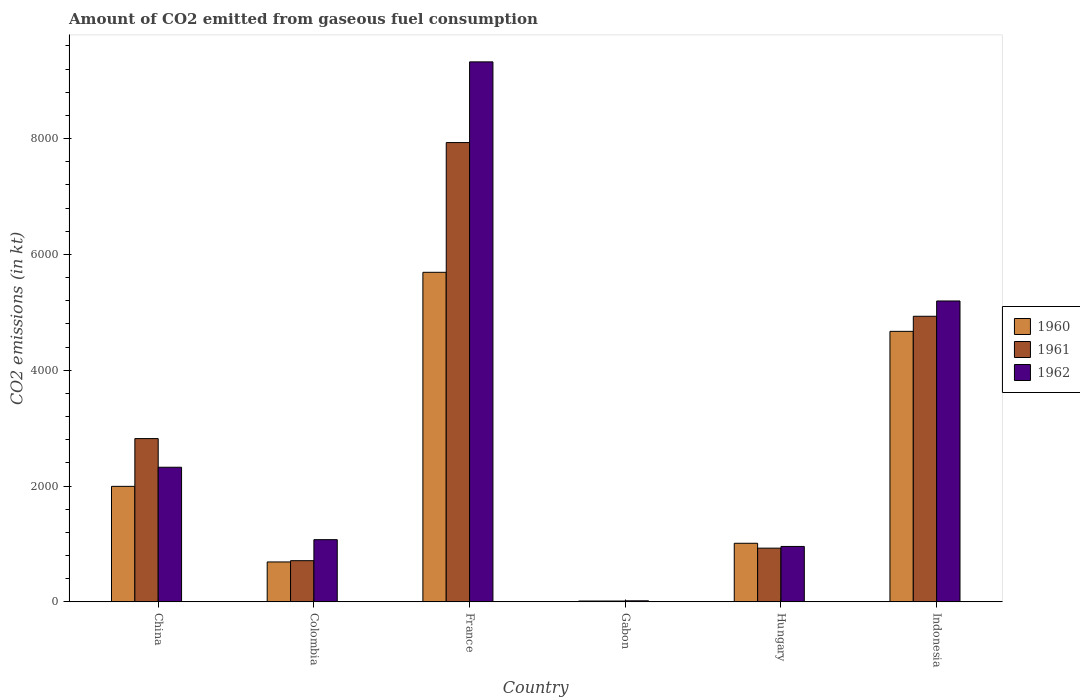How many groups of bars are there?
Offer a very short reply. 6. Are the number of bars per tick equal to the number of legend labels?
Offer a very short reply. Yes. Are the number of bars on each tick of the X-axis equal?
Provide a short and direct response. Yes. How many bars are there on the 5th tick from the right?
Offer a very short reply. 3. What is the label of the 2nd group of bars from the left?
Your response must be concise. Colombia. What is the amount of CO2 emitted in 1962 in Colombia?
Offer a terse response. 1074.43. Across all countries, what is the maximum amount of CO2 emitted in 1960?
Your response must be concise. 5691.18. Across all countries, what is the minimum amount of CO2 emitted in 1962?
Provide a short and direct response. 18.34. In which country was the amount of CO2 emitted in 1961 maximum?
Your response must be concise. France. In which country was the amount of CO2 emitted in 1960 minimum?
Ensure brevity in your answer.  Gabon. What is the total amount of CO2 emitted in 1960 in the graph?
Your answer should be very brief. 1.41e+04. What is the difference between the amount of CO2 emitted in 1961 in China and that in Indonesia?
Give a very brief answer. -2112.19. What is the difference between the amount of CO2 emitted in 1960 in Hungary and the amount of CO2 emitted in 1962 in Gabon?
Your answer should be compact. 993.76. What is the average amount of CO2 emitted in 1961 per country?
Give a very brief answer. 2889.6. What is the difference between the amount of CO2 emitted of/in 1962 and amount of CO2 emitted of/in 1960 in France?
Keep it short and to the point. 3634. What is the ratio of the amount of CO2 emitted in 1962 in Hungary to that in Indonesia?
Give a very brief answer. 0.18. Is the difference between the amount of CO2 emitted in 1962 in Colombia and Gabon greater than the difference between the amount of CO2 emitted in 1960 in Colombia and Gabon?
Your answer should be very brief. Yes. What is the difference between the highest and the second highest amount of CO2 emitted in 1962?
Keep it short and to the point. -2871.26. What is the difference between the highest and the lowest amount of CO2 emitted in 1960?
Make the answer very short. 5676.52. In how many countries, is the amount of CO2 emitted in 1960 greater than the average amount of CO2 emitted in 1960 taken over all countries?
Your response must be concise. 2. What does the 3rd bar from the left in Indonesia represents?
Give a very brief answer. 1962. What does the 1st bar from the right in Colombia represents?
Provide a succinct answer. 1962. Is it the case that in every country, the sum of the amount of CO2 emitted in 1960 and amount of CO2 emitted in 1961 is greater than the amount of CO2 emitted in 1962?
Your answer should be very brief. Yes. How many countries are there in the graph?
Offer a very short reply. 6. Does the graph contain grids?
Provide a succinct answer. No. Where does the legend appear in the graph?
Provide a short and direct response. Center right. How many legend labels are there?
Give a very brief answer. 3. What is the title of the graph?
Make the answer very short. Amount of CO2 emitted from gaseous fuel consumption. Does "1962" appear as one of the legend labels in the graph?
Make the answer very short. Yes. What is the label or title of the X-axis?
Your answer should be very brief. Country. What is the label or title of the Y-axis?
Offer a very short reply. CO2 emissions (in kt). What is the CO2 emissions (in kt) in 1960 in China?
Your answer should be very brief. 1994.85. What is the CO2 emissions (in kt) of 1961 in China?
Offer a very short reply. 2819.92. What is the CO2 emissions (in kt) in 1962 in China?
Offer a terse response. 2324.88. What is the CO2 emissions (in kt) in 1960 in Colombia?
Provide a short and direct response. 689.4. What is the CO2 emissions (in kt) in 1961 in Colombia?
Ensure brevity in your answer.  711.4. What is the CO2 emissions (in kt) of 1962 in Colombia?
Provide a succinct answer. 1074.43. What is the CO2 emissions (in kt) in 1960 in France?
Keep it short and to the point. 5691.18. What is the CO2 emissions (in kt) in 1961 in France?
Keep it short and to the point. 7931.72. What is the CO2 emissions (in kt) of 1962 in France?
Your answer should be very brief. 9325.18. What is the CO2 emissions (in kt) in 1960 in Gabon?
Your response must be concise. 14.67. What is the CO2 emissions (in kt) in 1961 in Gabon?
Your answer should be very brief. 14.67. What is the CO2 emissions (in kt) of 1962 in Gabon?
Offer a very short reply. 18.34. What is the CO2 emissions (in kt) of 1960 in Hungary?
Keep it short and to the point. 1012.09. What is the CO2 emissions (in kt) in 1961 in Hungary?
Offer a very short reply. 927.75. What is the CO2 emissions (in kt) of 1962 in Hungary?
Offer a very short reply. 957.09. What is the CO2 emissions (in kt) in 1960 in Indonesia?
Your answer should be compact. 4671.76. What is the CO2 emissions (in kt) in 1961 in Indonesia?
Offer a very short reply. 4932.11. What is the CO2 emissions (in kt) in 1962 in Indonesia?
Your response must be concise. 5196.14. Across all countries, what is the maximum CO2 emissions (in kt) of 1960?
Your answer should be compact. 5691.18. Across all countries, what is the maximum CO2 emissions (in kt) of 1961?
Provide a succinct answer. 7931.72. Across all countries, what is the maximum CO2 emissions (in kt) in 1962?
Your answer should be compact. 9325.18. Across all countries, what is the minimum CO2 emissions (in kt) of 1960?
Ensure brevity in your answer.  14.67. Across all countries, what is the minimum CO2 emissions (in kt) in 1961?
Your answer should be compact. 14.67. Across all countries, what is the minimum CO2 emissions (in kt) in 1962?
Make the answer very short. 18.34. What is the total CO2 emissions (in kt) in 1960 in the graph?
Offer a terse response. 1.41e+04. What is the total CO2 emissions (in kt) of 1961 in the graph?
Provide a short and direct response. 1.73e+04. What is the total CO2 emissions (in kt) in 1962 in the graph?
Offer a terse response. 1.89e+04. What is the difference between the CO2 emissions (in kt) in 1960 in China and that in Colombia?
Provide a short and direct response. 1305.45. What is the difference between the CO2 emissions (in kt) in 1961 in China and that in Colombia?
Give a very brief answer. 2108.53. What is the difference between the CO2 emissions (in kt) in 1962 in China and that in Colombia?
Give a very brief answer. 1250.45. What is the difference between the CO2 emissions (in kt) in 1960 in China and that in France?
Keep it short and to the point. -3696.34. What is the difference between the CO2 emissions (in kt) in 1961 in China and that in France?
Give a very brief answer. -5111.8. What is the difference between the CO2 emissions (in kt) in 1962 in China and that in France?
Your answer should be very brief. -7000.3. What is the difference between the CO2 emissions (in kt) in 1960 in China and that in Gabon?
Give a very brief answer. 1980.18. What is the difference between the CO2 emissions (in kt) of 1961 in China and that in Gabon?
Offer a very short reply. 2805.26. What is the difference between the CO2 emissions (in kt) in 1962 in China and that in Gabon?
Ensure brevity in your answer.  2306.54. What is the difference between the CO2 emissions (in kt) of 1960 in China and that in Hungary?
Your answer should be compact. 982.76. What is the difference between the CO2 emissions (in kt) in 1961 in China and that in Hungary?
Provide a succinct answer. 1892.17. What is the difference between the CO2 emissions (in kt) in 1962 in China and that in Hungary?
Provide a succinct answer. 1367.79. What is the difference between the CO2 emissions (in kt) of 1960 in China and that in Indonesia?
Make the answer very short. -2676.91. What is the difference between the CO2 emissions (in kt) of 1961 in China and that in Indonesia?
Offer a very short reply. -2112.19. What is the difference between the CO2 emissions (in kt) in 1962 in China and that in Indonesia?
Provide a succinct answer. -2871.26. What is the difference between the CO2 emissions (in kt) in 1960 in Colombia and that in France?
Your answer should be compact. -5001.79. What is the difference between the CO2 emissions (in kt) of 1961 in Colombia and that in France?
Offer a very short reply. -7220.32. What is the difference between the CO2 emissions (in kt) in 1962 in Colombia and that in France?
Provide a succinct answer. -8250.75. What is the difference between the CO2 emissions (in kt) of 1960 in Colombia and that in Gabon?
Provide a succinct answer. 674.73. What is the difference between the CO2 emissions (in kt) of 1961 in Colombia and that in Gabon?
Offer a very short reply. 696.73. What is the difference between the CO2 emissions (in kt) of 1962 in Colombia and that in Gabon?
Your answer should be very brief. 1056.1. What is the difference between the CO2 emissions (in kt) of 1960 in Colombia and that in Hungary?
Provide a short and direct response. -322.7. What is the difference between the CO2 emissions (in kt) in 1961 in Colombia and that in Hungary?
Your answer should be very brief. -216.35. What is the difference between the CO2 emissions (in kt) of 1962 in Colombia and that in Hungary?
Provide a short and direct response. 117.34. What is the difference between the CO2 emissions (in kt) in 1960 in Colombia and that in Indonesia?
Offer a very short reply. -3982.36. What is the difference between the CO2 emissions (in kt) of 1961 in Colombia and that in Indonesia?
Make the answer very short. -4220.72. What is the difference between the CO2 emissions (in kt) in 1962 in Colombia and that in Indonesia?
Give a very brief answer. -4121.71. What is the difference between the CO2 emissions (in kt) of 1960 in France and that in Gabon?
Your answer should be compact. 5676.52. What is the difference between the CO2 emissions (in kt) of 1961 in France and that in Gabon?
Make the answer very short. 7917.05. What is the difference between the CO2 emissions (in kt) in 1962 in France and that in Gabon?
Keep it short and to the point. 9306.85. What is the difference between the CO2 emissions (in kt) in 1960 in France and that in Hungary?
Give a very brief answer. 4679.09. What is the difference between the CO2 emissions (in kt) in 1961 in France and that in Hungary?
Your response must be concise. 7003.97. What is the difference between the CO2 emissions (in kt) in 1962 in France and that in Hungary?
Make the answer very short. 8368.09. What is the difference between the CO2 emissions (in kt) in 1960 in France and that in Indonesia?
Provide a short and direct response. 1019.43. What is the difference between the CO2 emissions (in kt) in 1961 in France and that in Indonesia?
Provide a short and direct response. 2999.61. What is the difference between the CO2 emissions (in kt) in 1962 in France and that in Indonesia?
Keep it short and to the point. 4129.04. What is the difference between the CO2 emissions (in kt) of 1960 in Gabon and that in Hungary?
Ensure brevity in your answer.  -997.42. What is the difference between the CO2 emissions (in kt) of 1961 in Gabon and that in Hungary?
Your answer should be very brief. -913.08. What is the difference between the CO2 emissions (in kt) of 1962 in Gabon and that in Hungary?
Give a very brief answer. -938.75. What is the difference between the CO2 emissions (in kt) of 1960 in Gabon and that in Indonesia?
Your response must be concise. -4657.09. What is the difference between the CO2 emissions (in kt) of 1961 in Gabon and that in Indonesia?
Keep it short and to the point. -4917.45. What is the difference between the CO2 emissions (in kt) in 1962 in Gabon and that in Indonesia?
Provide a short and direct response. -5177.8. What is the difference between the CO2 emissions (in kt) in 1960 in Hungary and that in Indonesia?
Offer a terse response. -3659.67. What is the difference between the CO2 emissions (in kt) in 1961 in Hungary and that in Indonesia?
Your answer should be compact. -4004.36. What is the difference between the CO2 emissions (in kt) in 1962 in Hungary and that in Indonesia?
Your response must be concise. -4239.05. What is the difference between the CO2 emissions (in kt) of 1960 in China and the CO2 emissions (in kt) of 1961 in Colombia?
Offer a terse response. 1283.45. What is the difference between the CO2 emissions (in kt) in 1960 in China and the CO2 emissions (in kt) in 1962 in Colombia?
Offer a very short reply. 920.42. What is the difference between the CO2 emissions (in kt) in 1961 in China and the CO2 emissions (in kt) in 1962 in Colombia?
Keep it short and to the point. 1745.49. What is the difference between the CO2 emissions (in kt) in 1960 in China and the CO2 emissions (in kt) in 1961 in France?
Ensure brevity in your answer.  -5936.87. What is the difference between the CO2 emissions (in kt) of 1960 in China and the CO2 emissions (in kt) of 1962 in France?
Ensure brevity in your answer.  -7330.33. What is the difference between the CO2 emissions (in kt) of 1961 in China and the CO2 emissions (in kt) of 1962 in France?
Offer a terse response. -6505.26. What is the difference between the CO2 emissions (in kt) of 1960 in China and the CO2 emissions (in kt) of 1961 in Gabon?
Offer a very short reply. 1980.18. What is the difference between the CO2 emissions (in kt) in 1960 in China and the CO2 emissions (in kt) in 1962 in Gabon?
Provide a succinct answer. 1976.51. What is the difference between the CO2 emissions (in kt) of 1961 in China and the CO2 emissions (in kt) of 1962 in Gabon?
Your answer should be compact. 2801.59. What is the difference between the CO2 emissions (in kt) in 1960 in China and the CO2 emissions (in kt) in 1961 in Hungary?
Your answer should be compact. 1067.1. What is the difference between the CO2 emissions (in kt) in 1960 in China and the CO2 emissions (in kt) in 1962 in Hungary?
Make the answer very short. 1037.76. What is the difference between the CO2 emissions (in kt) of 1961 in China and the CO2 emissions (in kt) of 1962 in Hungary?
Provide a short and direct response. 1862.84. What is the difference between the CO2 emissions (in kt) in 1960 in China and the CO2 emissions (in kt) in 1961 in Indonesia?
Your answer should be very brief. -2937.27. What is the difference between the CO2 emissions (in kt) of 1960 in China and the CO2 emissions (in kt) of 1962 in Indonesia?
Ensure brevity in your answer.  -3201.29. What is the difference between the CO2 emissions (in kt) in 1961 in China and the CO2 emissions (in kt) in 1962 in Indonesia?
Your answer should be compact. -2376.22. What is the difference between the CO2 emissions (in kt) in 1960 in Colombia and the CO2 emissions (in kt) in 1961 in France?
Your answer should be compact. -7242.32. What is the difference between the CO2 emissions (in kt) of 1960 in Colombia and the CO2 emissions (in kt) of 1962 in France?
Your answer should be very brief. -8635.78. What is the difference between the CO2 emissions (in kt) in 1961 in Colombia and the CO2 emissions (in kt) in 1962 in France?
Offer a terse response. -8613.78. What is the difference between the CO2 emissions (in kt) in 1960 in Colombia and the CO2 emissions (in kt) in 1961 in Gabon?
Your answer should be compact. 674.73. What is the difference between the CO2 emissions (in kt) in 1960 in Colombia and the CO2 emissions (in kt) in 1962 in Gabon?
Make the answer very short. 671.06. What is the difference between the CO2 emissions (in kt) in 1961 in Colombia and the CO2 emissions (in kt) in 1962 in Gabon?
Offer a terse response. 693.06. What is the difference between the CO2 emissions (in kt) in 1960 in Colombia and the CO2 emissions (in kt) in 1961 in Hungary?
Your answer should be compact. -238.35. What is the difference between the CO2 emissions (in kt) in 1960 in Colombia and the CO2 emissions (in kt) in 1962 in Hungary?
Provide a short and direct response. -267.69. What is the difference between the CO2 emissions (in kt) in 1961 in Colombia and the CO2 emissions (in kt) in 1962 in Hungary?
Your answer should be compact. -245.69. What is the difference between the CO2 emissions (in kt) in 1960 in Colombia and the CO2 emissions (in kt) in 1961 in Indonesia?
Offer a terse response. -4242.72. What is the difference between the CO2 emissions (in kt) of 1960 in Colombia and the CO2 emissions (in kt) of 1962 in Indonesia?
Provide a short and direct response. -4506.74. What is the difference between the CO2 emissions (in kt) of 1961 in Colombia and the CO2 emissions (in kt) of 1962 in Indonesia?
Offer a very short reply. -4484.74. What is the difference between the CO2 emissions (in kt) of 1960 in France and the CO2 emissions (in kt) of 1961 in Gabon?
Make the answer very short. 5676.52. What is the difference between the CO2 emissions (in kt) in 1960 in France and the CO2 emissions (in kt) in 1962 in Gabon?
Your answer should be compact. 5672.85. What is the difference between the CO2 emissions (in kt) of 1961 in France and the CO2 emissions (in kt) of 1962 in Gabon?
Give a very brief answer. 7913.39. What is the difference between the CO2 emissions (in kt) of 1960 in France and the CO2 emissions (in kt) of 1961 in Hungary?
Provide a succinct answer. 4763.43. What is the difference between the CO2 emissions (in kt) in 1960 in France and the CO2 emissions (in kt) in 1962 in Hungary?
Keep it short and to the point. 4734.1. What is the difference between the CO2 emissions (in kt) in 1961 in France and the CO2 emissions (in kt) in 1962 in Hungary?
Offer a terse response. 6974.63. What is the difference between the CO2 emissions (in kt) in 1960 in France and the CO2 emissions (in kt) in 1961 in Indonesia?
Make the answer very short. 759.07. What is the difference between the CO2 emissions (in kt) of 1960 in France and the CO2 emissions (in kt) of 1962 in Indonesia?
Your response must be concise. 495.05. What is the difference between the CO2 emissions (in kt) in 1961 in France and the CO2 emissions (in kt) in 1962 in Indonesia?
Offer a very short reply. 2735.58. What is the difference between the CO2 emissions (in kt) of 1960 in Gabon and the CO2 emissions (in kt) of 1961 in Hungary?
Give a very brief answer. -913.08. What is the difference between the CO2 emissions (in kt) of 1960 in Gabon and the CO2 emissions (in kt) of 1962 in Hungary?
Ensure brevity in your answer.  -942.42. What is the difference between the CO2 emissions (in kt) of 1961 in Gabon and the CO2 emissions (in kt) of 1962 in Hungary?
Give a very brief answer. -942.42. What is the difference between the CO2 emissions (in kt) of 1960 in Gabon and the CO2 emissions (in kt) of 1961 in Indonesia?
Your response must be concise. -4917.45. What is the difference between the CO2 emissions (in kt) of 1960 in Gabon and the CO2 emissions (in kt) of 1962 in Indonesia?
Offer a very short reply. -5181.47. What is the difference between the CO2 emissions (in kt) in 1961 in Gabon and the CO2 emissions (in kt) in 1962 in Indonesia?
Your answer should be very brief. -5181.47. What is the difference between the CO2 emissions (in kt) in 1960 in Hungary and the CO2 emissions (in kt) in 1961 in Indonesia?
Keep it short and to the point. -3920.02. What is the difference between the CO2 emissions (in kt) in 1960 in Hungary and the CO2 emissions (in kt) in 1962 in Indonesia?
Your answer should be compact. -4184.05. What is the difference between the CO2 emissions (in kt) in 1961 in Hungary and the CO2 emissions (in kt) in 1962 in Indonesia?
Offer a terse response. -4268.39. What is the average CO2 emissions (in kt) of 1960 per country?
Make the answer very short. 2345.66. What is the average CO2 emissions (in kt) of 1961 per country?
Offer a terse response. 2889.6. What is the average CO2 emissions (in kt) of 1962 per country?
Provide a short and direct response. 3149.34. What is the difference between the CO2 emissions (in kt) of 1960 and CO2 emissions (in kt) of 1961 in China?
Your answer should be very brief. -825.08. What is the difference between the CO2 emissions (in kt) of 1960 and CO2 emissions (in kt) of 1962 in China?
Provide a short and direct response. -330.03. What is the difference between the CO2 emissions (in kt) of 1961 and CO2 emissions (in kt) of 1962 in China?
Offer a terse response. 495.05. What is the difference between the CO2 emissions (in kt) in 1960 and CO2 emissions (in kt) in 1961 in Colombia?
Offer a terse response. -22. What is the difference between the CO2 emissions (in kt) in 1960 and CO2 emissions (in kt) in 1962 in Colombia?
Offer a terse response. -385.04. What is the difference between the CO2 emissions (in kt) of 1961 and CO2 emissions (in kt) of 1962 in Colombia?
Give a very brief answer. -363.03. What is the difference between the CO2 emissions (in kt) of 1960 and CO2 emissions (in kt) of 1961 in France?
Your answer should be compact. -2240.54. What is the difference between the CO2 emissions (in kt) in 1960 and CO2 emissions (in kt) in 1962 in France?
Ensure brevity in your answer.  -3634. What is the difference between the CO2 emissions (in kt) of 1961 and CO2 emissions (in kt) of 1962 in France?
Your answer should be compact. -1393.46. What is the difference between the CO2 emissions (in kt) in 1960 and CO2 emissions (in kt) in 1962 in Gabon?
Your answer should be very brief. -3.67. What is the difference between the CO2 emissions (in kt) in 1961 and CO2 emissions (in kt) in 1962 in Gabon?
Your answer should be very brief. -3.67. What is the difference between the CO2 emissions (in kt) in 1960 and CO2 emissions (in kt) in 1961 in Hungary?
Keep it short and to the point. 84.34. What is the difference between the CO2 emissions (in kt) in 1960 and CO2 emissions (in kt) in 1962 in Hungary?
Give a very brief answer. 55.01. What is the difference between the CO2 emissions (in kt) of 1961 and CO2 emissions (in kt) of 1962 in Hungary?
Provide a short and direct response. -29.34. What is the difference between the CO2 emissions (in kt) in 1960 and CO2 emissions (in kt) in 1961 in Indonesia?
Offer a very short reply. -260.36. What is the difference between the CO2 emissions (in kt) in 1960 and CO2 emissions (in kt) in 1962 in Indonesia?
Offer a terse response. -524.38. What is the difference between the CO2 emissions (in kt) of 1961 and CO2 emissions (in kt) of 1962 in Indonesia?
Provide a succinct answer. -264.02. What is the ratio of the CO2 emissions (in kt) of 1960 in China to that in Colombia?
Provide a succinct answer. 2.89. What is the ratio of the CO2 emissions (in kt) in 1961 in China to that in Colombia?
Your response must be concise. 3.96. What is the ratio of the CO2 emissions (in kt) in 1962 in China to that in Colombia?
Provide a short and direct response. 2.16. What is the ratio of the CO2 emissions (in kt) in 1960 in China to that in France?
Provide a succinct answer. 0.35. What is the ratio of the CO2 emissions (in kt) of 1961 in China to that in France?
Make the answer very short. 0.36. What is the ratio of the CO2 emissions (in kt) in 1962 in China to that in France?
Give a very brief answer. 0.25. What is the ratio of the CO2 emissions (in kt) of 1960 in China to that in Gabon?
Ensure brevity in your answer.  136. What is the ratio of the CO2 emissions (in kt) of 1961 in China to that in Gabon?
Your answer should be very brief. 192.25. What is the ratio of the CO2 emissions (in kt) of 1962 in China to that in Gabon?
Offer a very short reply. 126.8. What is the ratio of the CO2 emissions (in kt) in 1960 in China to that in Hungary?
Your answer should be very brief. 1.97. What is the ratio of the CO2 emissions (in kt) of 1961 in China to that in Hungary?
Your response must be concise. 3.04. What is the ratio of the CO2 emissions (in kt) in 1962 in China to that in Hungary?
Provide a succinct answer. 2.43. What is the ratio of the CO2 emissions (in kt) of 1960 in China to that in Indonesia?
Provide a short and direct response. 0.43. What is the ratio of the CO2 emissions (in kt) of 1961 in China to that in Indonesia?
Make the answer very short. 0.57. What is the ratio of the CO2 emissions (in kt) of 1962 in China to that in Indonesia?
Offer a very short reply. 0.45. What is the ratio of the CO2 emissions (in kt) in 1960 in Colombia to that in France?
Keep it short and to the point. 0.12. What is the ratio of the CO2 emissions (in kt) of 1961 in Colombia to that in France?
Provide a short and direct response. 0.09. What is the ratio of the CO2 emissions (in kt) in 1962 in Colombia to that in France?
Provide a succinct answer. 0.12. What is the ratio of the CO2 emissions (in kt) in 1960 in Colombia to that in Gabon?
Give a very brief answer. 47. What is the ratio of the CO2 emissions (in kt) of 1961 in Colombia to that in Gabon?
Ensure brevity in your answer.  48.5. What is the ratio of the CO2 emissions (in kt) in 1962 in Colombia to that in Gabon?
Offer a terse response. 58.6. What is the ratio of the CO2 emissions (in kt) in 1960 in Colombia to that in Hungary?
Provide a succinct answer. 0.68. What is the ratio of the CO2 emissions (in kt) in 1961 in Colombia to that in Hungary?
Provide a succinct answer. 0.77. What is the ratio of the CO2 emissions (in kt) in 1962 in Colombia to that in Hungary?
Give a very brief answer. 1.12. What is the ratio of the CO2 emissions (in kt) in 1960 in Colombia to that in Indonesia?
Offer a very short reply. 0.15. What is the ratio of the CO2 emissions (in kt) of 1961 in Colombia to that in Indonesia?
Keep it short and to the point. 0.14. What is the ratio of the CO2 emissions (in kt) of 1962 in Colombia to that in Indonesia?
Keep it short and to the point. 0.21. What is the ratio of the CO2 emissions (in kt) in 1960 in France to that in Gabon?
Your answer should be very brief. 388. What is the ratio of the CO2 emissions (in kt) in 1961 in France to that in Gabon?
Provide a succinct answer. 540.75. What is the ratio of the CO2 emissions (in kt) of 1962 in France to that in Gabon?
Provide a succinct answer. 508.6. What is the ratio of the CO2 emissions (in kt) in 1960 in France to that in Hungary?
Offer a very short reply. 5.62. What is the ratio of the CO2 emissions (in kt) of 1961 in France to that in Hungary?
Your answer should be very brief. 8.55. What is the ratio of the CO2 emissions (in kt) of 1962 in France to that in Hungary?
Provide a short and direct response. 9.74. What is the ratio of the CO2 emissions (in kt) in 1960 in France to that in Indonesia?
Your response must be concise. 1.22. What is the ratio of the CO2 emissions (in kt) in 1961 in France to that in Indonesia?
Ensure brevity in your answer.  1.61. What is the ratio of the CO2 emissions (in kt) of 1962 in France to that in Indonesia?
Your answer should be very brief. 1.79. What is the ratio of the CO2 emissions (in kt) of 1960 in Gabon to that in Hungary?
Give a very brief answer. 0.01. What is the ratio of the CO2 emissions (in kt) of 1961 in Gabon to that in Hungary?
Offer a terse response. 0.02. What is the ratio of the CO2 emissions (in kt) of 1962 in Gabon to that in Hungary?
Provide a succinct answer. 0.02. What is the ratio of the CO2 emissions (in kt) of 1960 in Gabon to that in Indonesia?
Provide a succinct answer. 0. What is the ratio of the CO2 emissions (in kt) of 1961 in Gabon to that in Indonesia?
Offer a terse response. 0. What is the ratio of the CO2 emissions (in kt) in 1962 in Gabon to that in Indonesia?
Provide a succinct answer. 0. What is the ratio of the CO2 emissions (in kt) of 1960 in Hungary to that in Indonesia?
Keep it short and to the point. 0.22. What is the ratio of the CO2 emissions (in kt) of 1961 in Hungary to that in Indonesia?
Keep it short and to the point. 0.19. What is the ratio of the CO2 emissions (in kt) of 1962 in Hungary to that in Indonesia?
Ensure brevity in your answer.  0.18. What is the difference between the highest and the second highest CO2 emissions (in kt) of 1960?
Provide a succinct answer. 1019.43. What is the difference between the highest and the second highest CO2 emissions (in kt) in 1961?
Keep it short and to the point. 2999.61. What is the difference between the highest and the second highest CO2 emissions (in kt) of 1962?
Your answer should be very brief. 4129.04. What is the difference between the highest and the lowest CO2 emissions (in kt) in 1960?
Your answer should be very brief. 5676.52. What is the difference between the highest and the lowest CO2 emissions (in kt) of 1961?
Your answer should be very brief. 7917.05. What is the difference between the highest and the lowest CO2 emissions (in kt) of 1962?
Ensure brevity in your answer.  9306.85. 